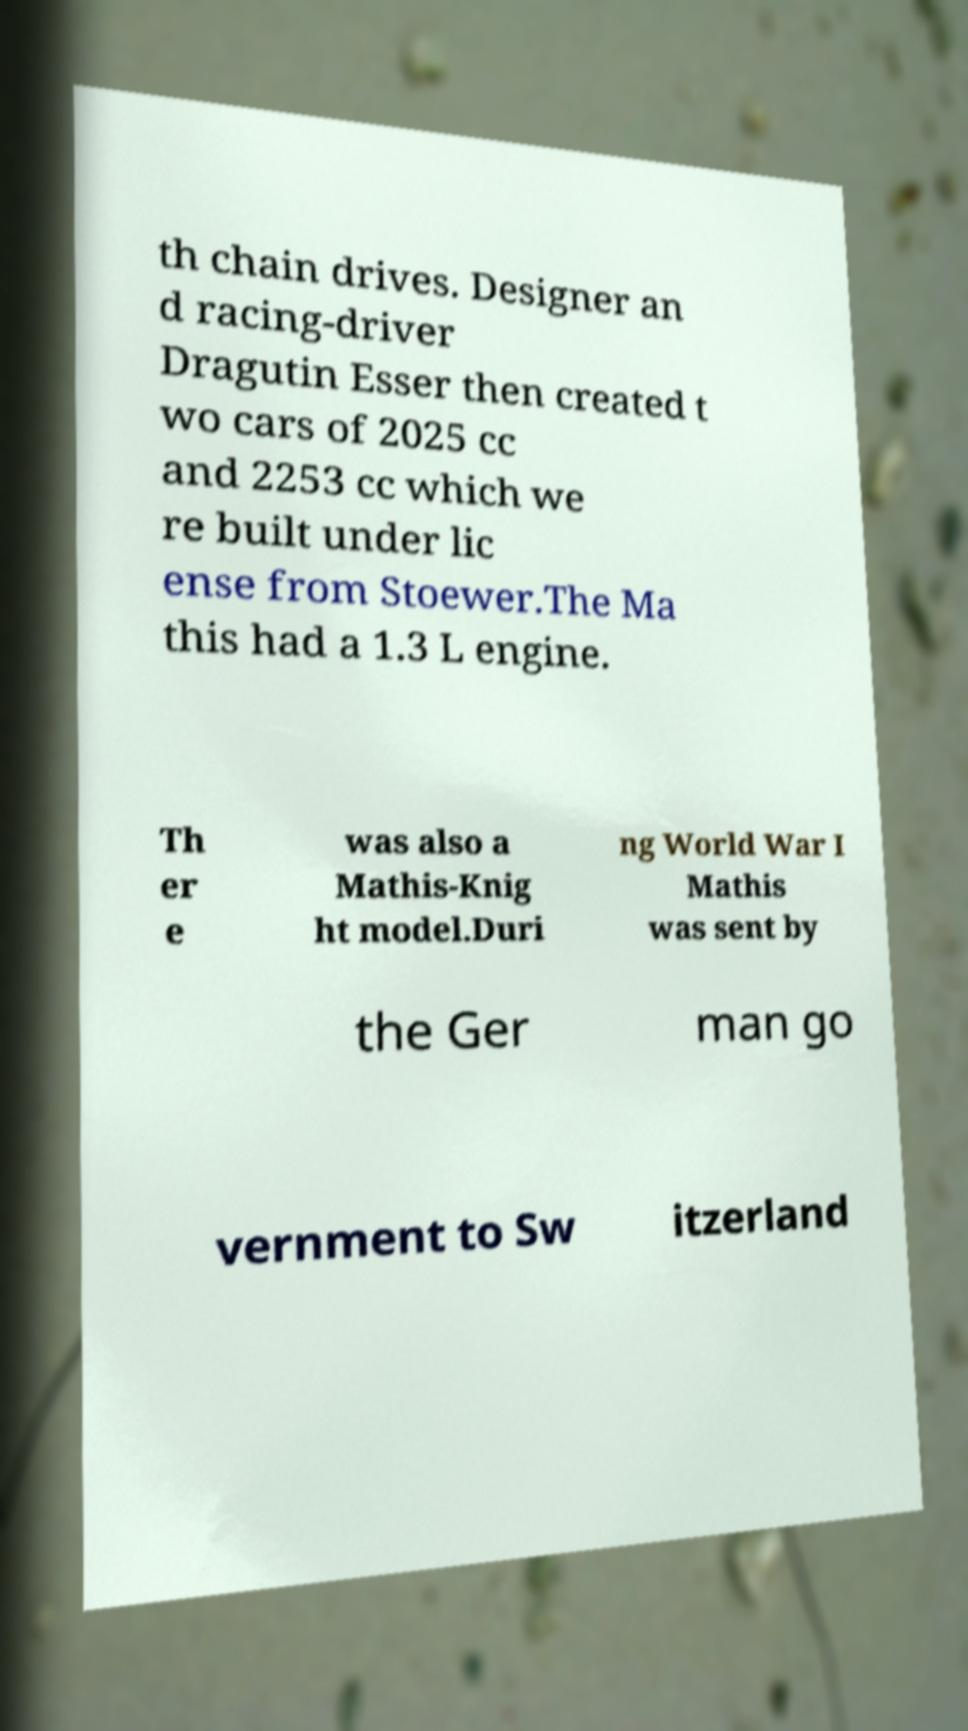What messages or text are displayed in this image? I need them in a readable, typed format. th chain drives. Designer an d racing-driver Dragutin Esser then created t wo cars of 2025 cc and 2253 cc which we re built under lic ense from Stoewer.The Ma this had a 1.3 L engine. Th er e was also a Mathis-Knig ht model.Duri ng World War I Mathis was sent by the Ger man go vernment to Sw itzerland 